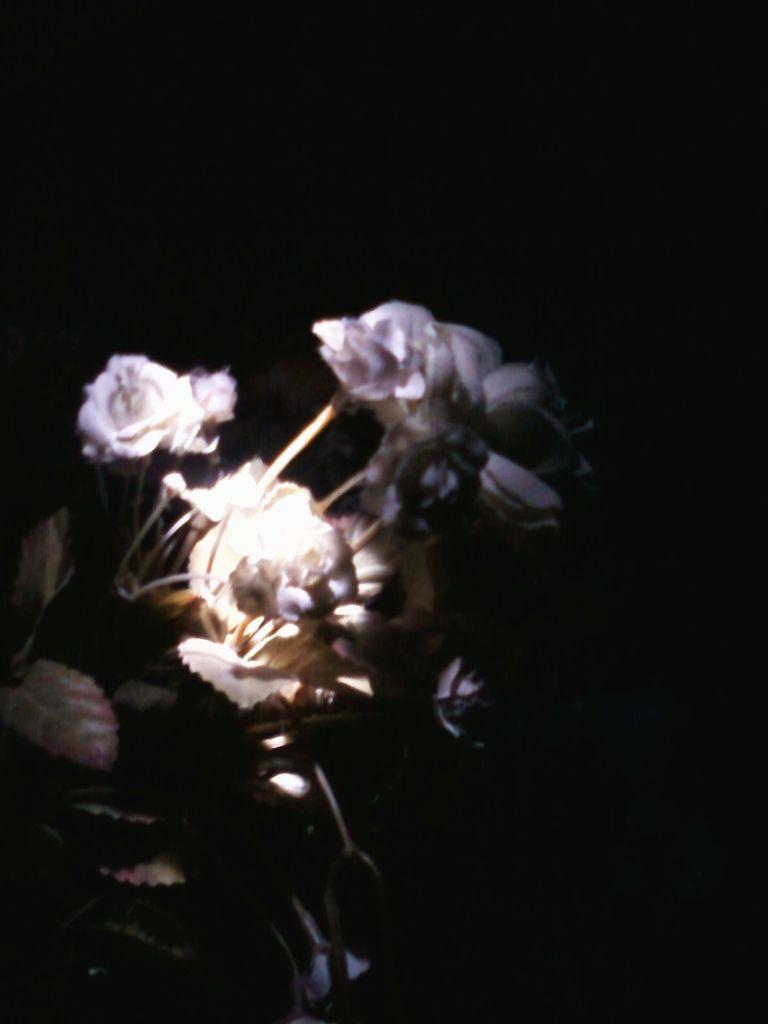What is the main subject of the image? The main subject of the image is planets. What is unique about these planets? The planets have flowers on them. What can be observed about the overall appearance of the image? The background of the image is dark. What type of war is being depicted on the planets in the image? There is no war depicted in the image; it features planets with flowers. What channel might be broadcasting this image? The image is not associated with a specific channel, as it is a still image and not a broadcast. 